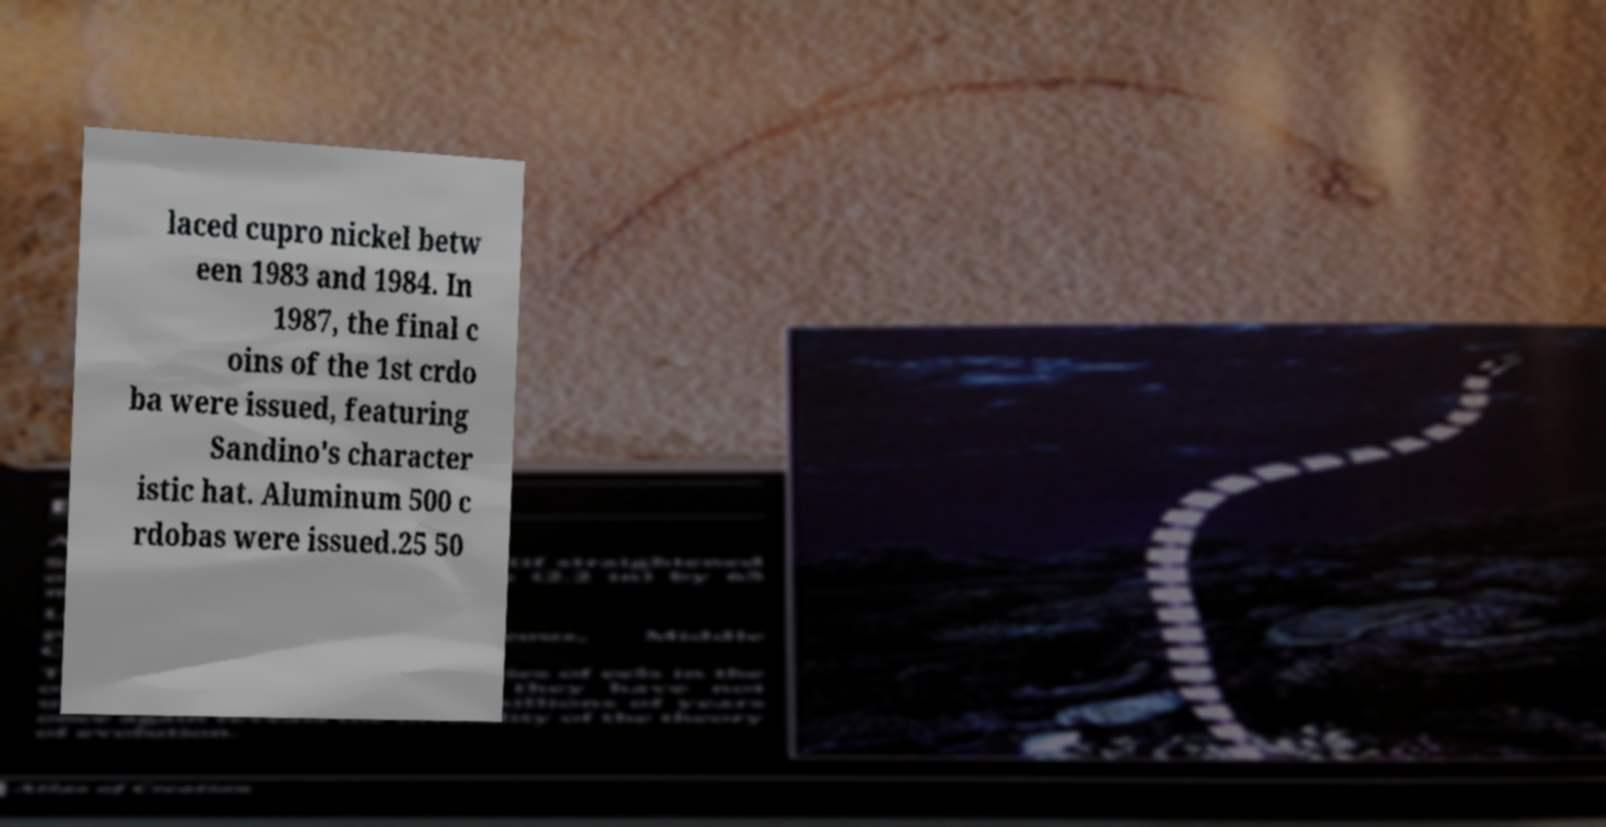There's text embedded in this image that I need extracted. Can you transcribe it verbatim? laced cupro nickel betw een 1983 and 1984. In 1987, the final c oins of the 1st crdo ba were issued, featuring Sandino's character istic hat. Aluminum 500 c rdobas were issued.25 50 